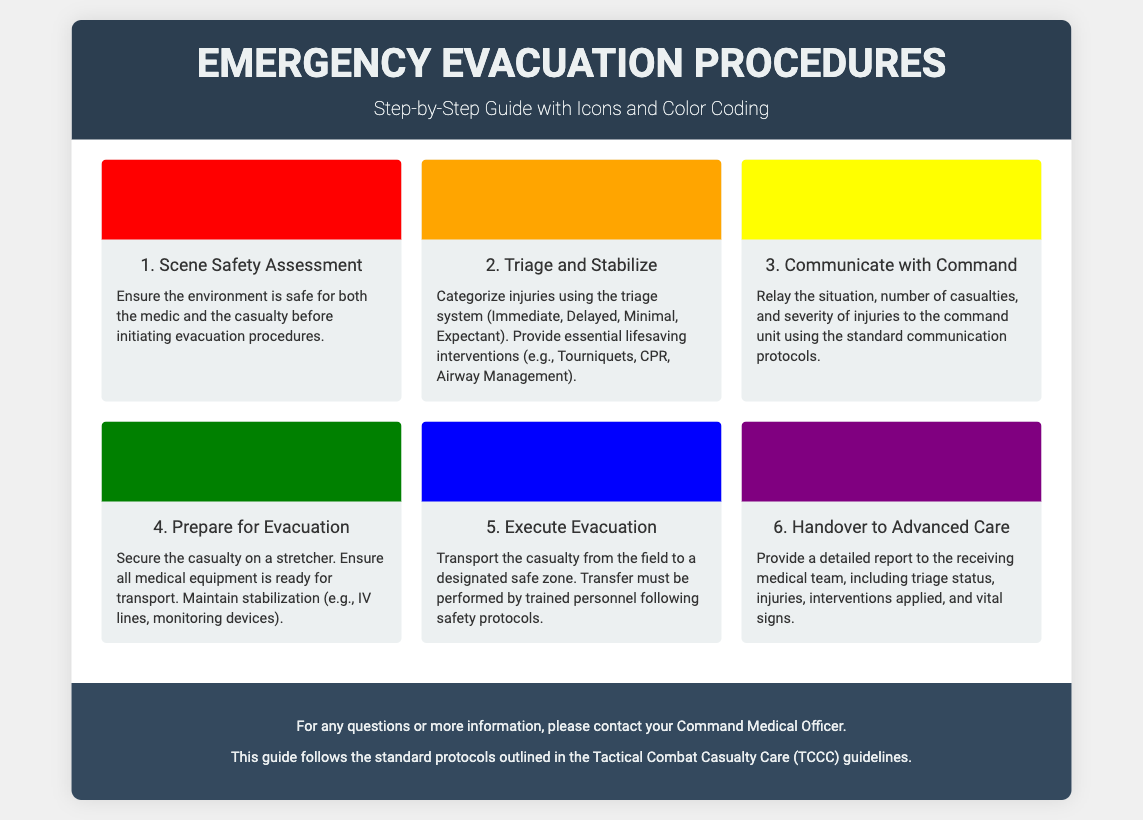What is the first step in the evacuation procedure? The first step is to conduct a Scene Safety Assessment to ensure the environment is safe.
Answer: Scene Safety Assessment What color represents the "Triage and Stabilize" step? The color representing "Triage and Stabilize" is orange.
Answer: Orange How many steps are outlined in the document? There are six steps outlined in the emergency evacuation procedures.
Answer: Six What should be secured on a stretcher during the evacuation preparation? The casualty should be secured on a stretcher during this preparation step.
Answer: Casualty What is the primary purpose of Step 3? The primary purpose of Step 3 is to communicate with command regarding the situation and casualties.
Answer: Communicate with Command Which step involves providing a report to the receiving medical team? The step that involves providing a report is the sixth step.
Answer: Handover to Advanced Care What lifesaving intervention is mentioned in Step 2? One lifesaving intervention mentioned is Tourniquets.
Answer: Tourniquets Identify the icon associated with Step 4. The icon associated with Step 4 is the preparation icon.
Answer: Preparation icon What do you need to maintain during Step 4? You need to maintain stabilization during Step 4.
Answer: Stabilization 